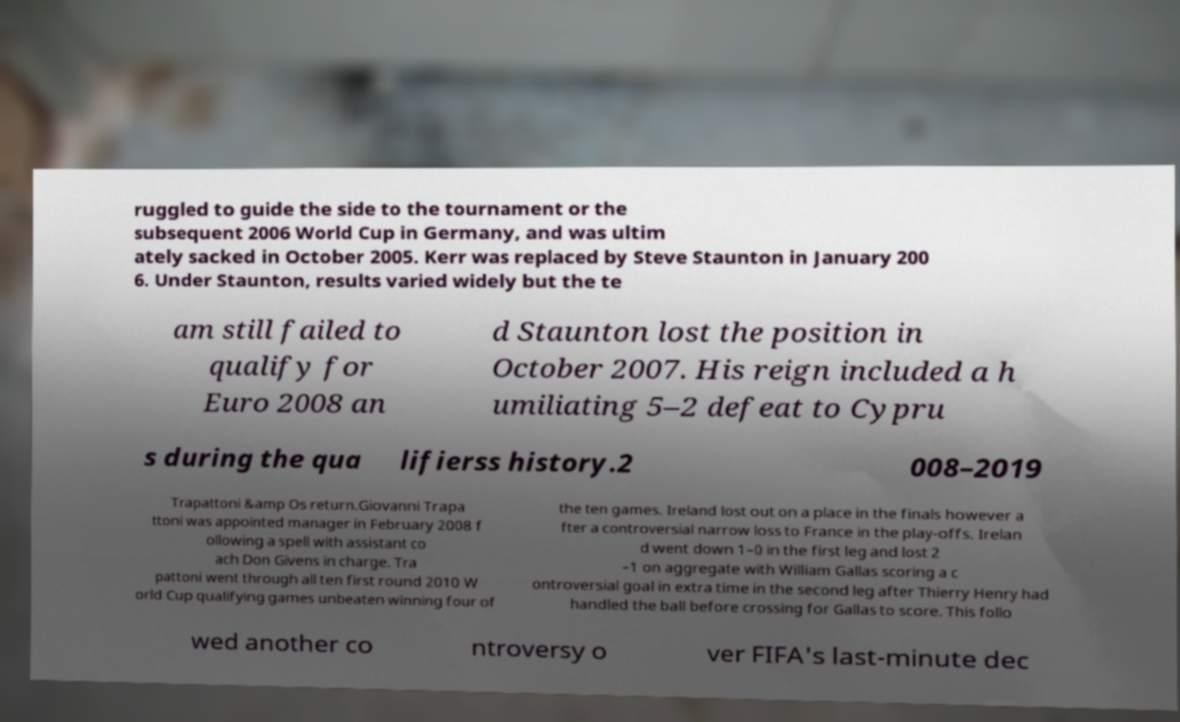Can you read and provide the text displayed in the image?This photo seems to have some interesting text. Can you extract and type it out for me? ruggled to guide the side to the tournament or the subsequent 2006 World Cup in Germany, and was ultim ately sacked in October 2005. Kerr was replaced by Steve Staunton in January 200 6. Under Staunton, results varied widely but the te am still failed to qualify for Euro 2008 an d Staunton lost the position in October 2007. His reign included a h umiliating 5–2 defeat to Cypru s during the qua lifierss history.2 008–2019 Trapattoni &amp Os return.Giovanni Trapa ttoni was appointed manager in February 2008 f ollowing a spell with assistant co ach Don Givens in charge. Tra pattoni went through all ten first round 2010 W orld Cup qualifying games unbeaten winning four of the ten games. Ireland lost out on a place in the finals however a fter a controversial narrow loss to France in the play-offs. Irelan d went down 1–0 in the first leg and lost 2 –1 on aggregate with William Gallas scoring a c ontroversial goal in extra time in the second leg after Thierry Henry had handled the ball before crossing for Gallas to score. This follo wed another co ntroversy o ver FIFA's last-minute dec 